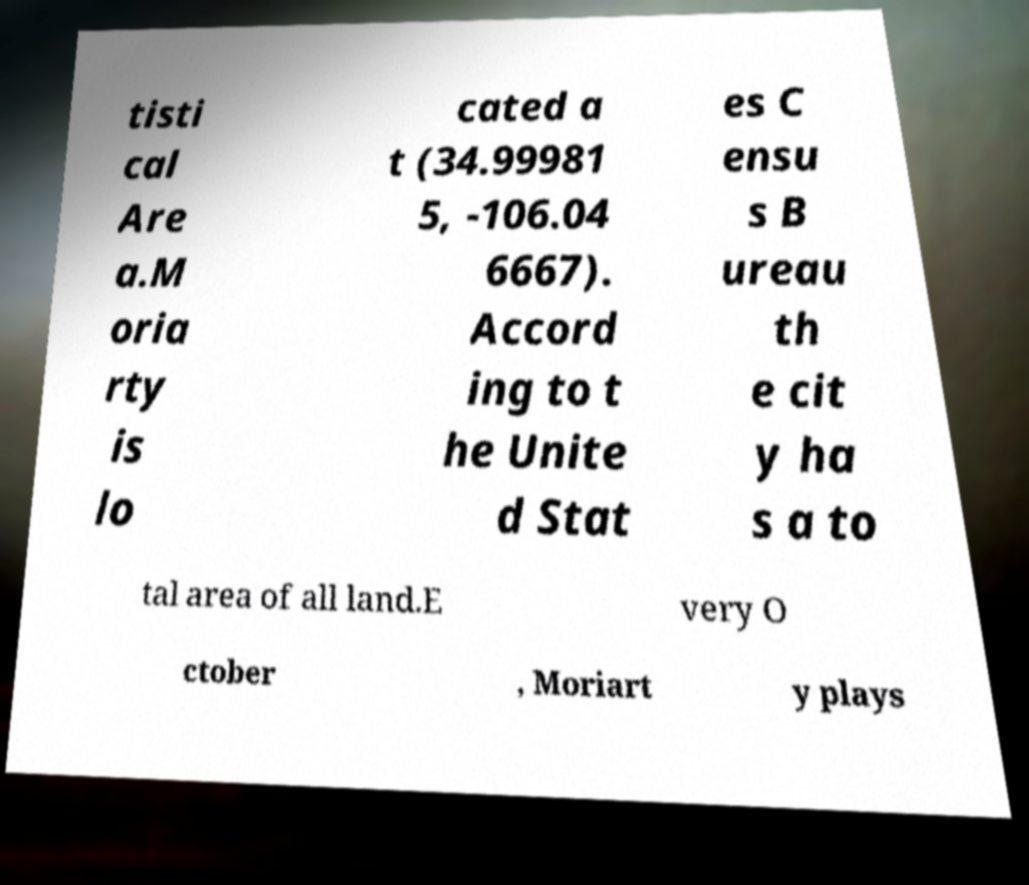There's text embedded in this image that I need extracted. Can you transcribe it verbatim? tisti cal Are a.M oria rty is lo cated a t (34.99981 5, -106.04 6667). Accord ing to t he Unite d Stat es C ensu s B ureau th e cit y ha s a to tal area of all land.E very O ctober , Moriart y plays 